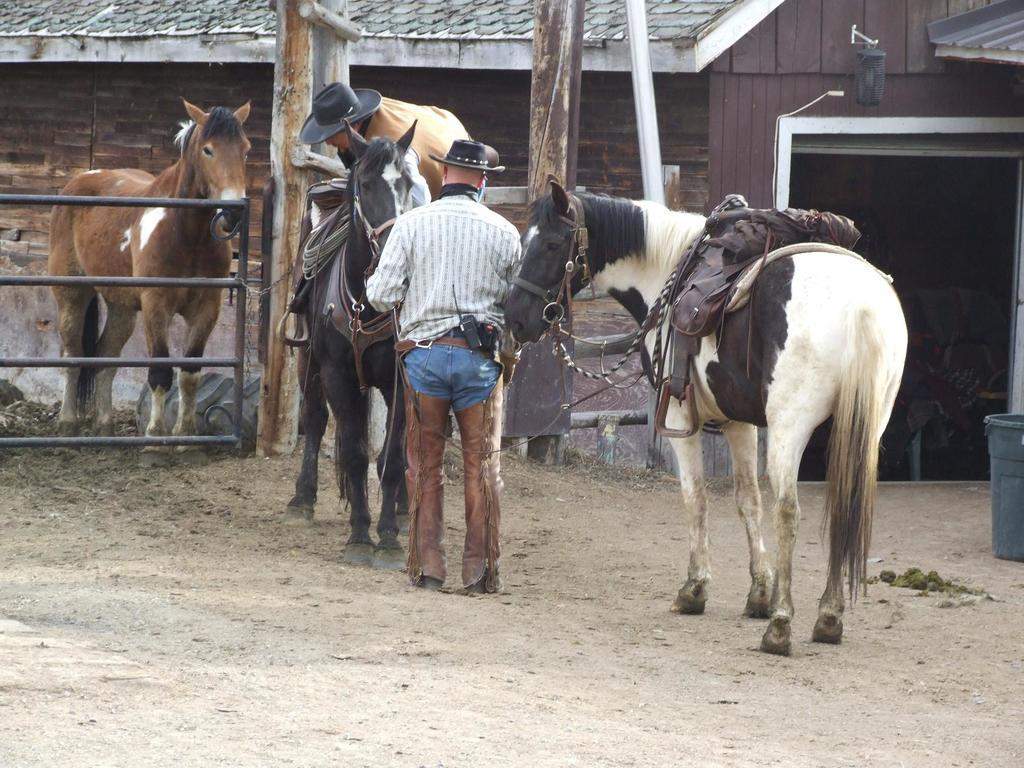What type of structure can be seen in the image? There is railing in the image. What animals are present in the image? There are horses in the image. Are there any people in the image? Yes, there are people in the image. What type of building or shelter is visible in the image? There is a shed in the image. What other objects can be seen in the image? There are poles and a bin in the image. What type of party is being held in the image? There is no indication of a party in the image. Can you tell me what question the person in the image is asking? There is no specific question being asked in the image. 